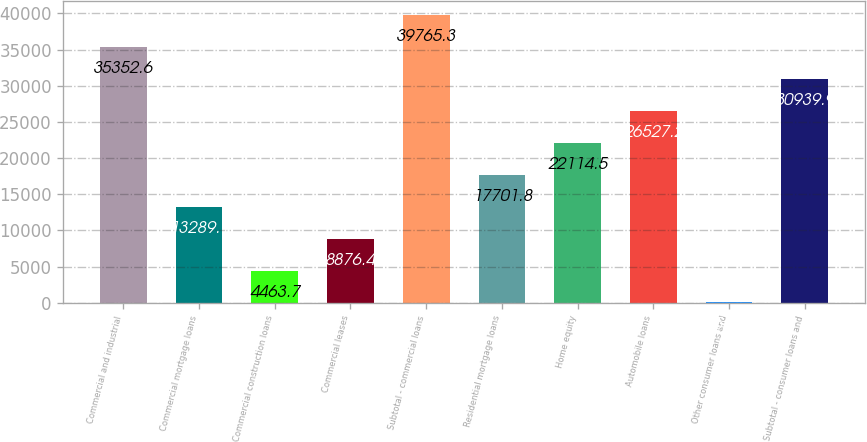Convert chart to OTSL. <chart><loc_0><loc_0><loc_500><loc_500><bar_chart><fcel>Commercial and industrial<fcel>Commercial mortgage loans<fcel>Commercial construction loans<fcel>Commercial leases<fcel>Subtotal - commercial loans<fcel>Residential mortgage loans<fcel>Home equity<fcel>Automobile loans<fcel>Other consumer loans and<fcel>Subtotal - consumer loans and<nl><fcel>35352.6<fcel>13289.1<fcel>4463.7<fcel>8876.4<fcel>39765.3<fcel>17701.8<fcel>22114.5<fcel>26527.2<fcel>51<fcel>30939.9<nl></chart> 